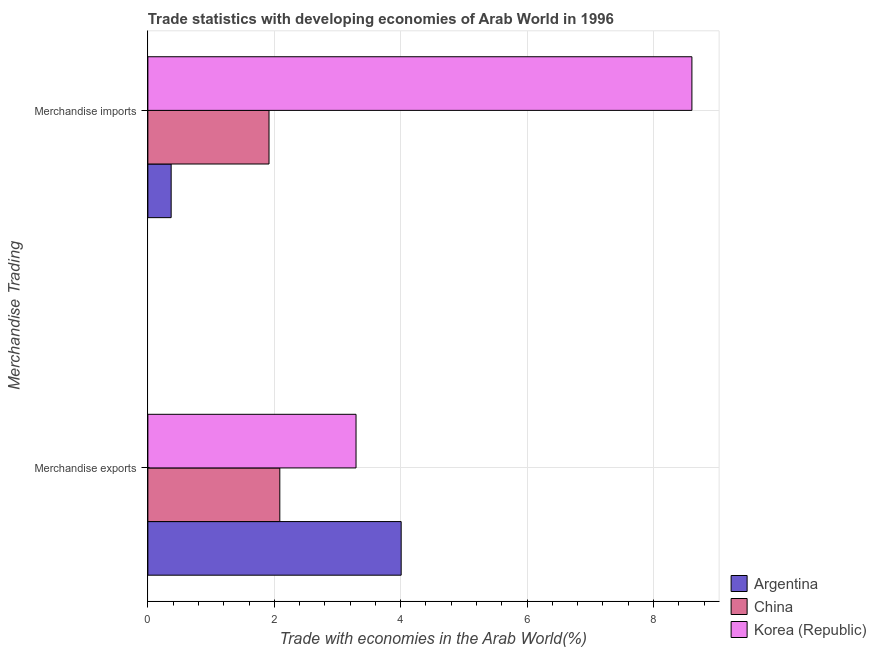How many different coloured bars are there?
Offer a very short reply. 3. How many groups of bars are there?
Keep it short and to the point. 2. Are the number of bars on each tick of the Y-axis equal?
Provide a succinct answer. Yes. How many bars are there on the 2nd tick from the bottom?
Your answer should be compact. 3. What is the label of the 1st group of bars from the top?
Offer a very short reply. Merchandise imports. What is the merchandise exports in Argentina?
Keep it short and to the point. 4.01. Across all countries, what is the maximum merchandise exports?
Your answer should be compact. 4.01. Across all countries, what is the minimum merchandise exports?
Give a very brief answer. 2.09. In which country was the merchandise exports maximum?
Your answer should be very brief. Argentina. In which country was the merchandise exports minimum?
Provide a succinct answer. China. What is the total merchandise imports in the graph?
Offer a very short reply. 10.89. What is the difference between the merchandise imports in Korea (Republic) and that in Argentina?
Offer a terse response. 8.24. What is the difference between the merchandise imports in China and the merchandise exports in Argentina?
Offer a very short reply. -2.09. What is the average merchandise imports per country?
Give a very brief answer. 3.63. What is the difference between the merchandise imports and merchandise exports in Korea (Republic)?
Your answer should be very brief. 5.31. What is the ratio of the merchandise imports in Argentina to that in Korea (Republic)?
Give a very brief answer. 0.04. Is the merchandise imports in Argentina less than that in Korea (Republic)?
Give a very brief answer. Yes. In how many countries, is the merchandise imports greater than the average merchandise imports taken over all countries?
Your answer should be very brief. 1. What does the 1st bar from the top in Merchandise exports represents?
Your answer should be very brief. Korea (Republic). What does the 3rd bar from the bottom in Merchandise imports represents?
Make the answer very short. Korea (Republic). How many bars are there?
Keep it short and to the point. 6. Are all the bars in the graph horizontal?
Provide a short and direct response. Yes. How many countries are there in the graph?
Your answer should be very brief. 3. What is the difference between two consecutive major ticks on the X-axis?
Ensure brevity in your answer.  2. Are the values on the major ticks of X-axis written in scientific E-notation?
Provide a short and direct response. No. Does the graph contain grids?
Offer a very short reply. Yes. What is the title of the graph?
Your answer should be compact. Trade statistics with developing economies of Arab World in 1996. Does "Israel" appear as one of the legend labels in the graph?
Your answer should be very brief. No. What is the label or title of the X-axis?
Your answer should be compact. Trade with economies in the Arab World(%). What is the label or title of the Y-axis?
Offer a terse response. Merchandise Trading. What is the Trade with economies in the Arab World(%) in Argentina in Merchandise exports?
Ensure brevity in your answer.  4.01. What is the Trade with economies in the Arab World(%) in China in Merchandise exports?
Offer a terse response. 2.09. What is the Trade with economies in the Arab World(%) of Korea (Republic) in Merchandise exports?
Your answer should be compact. 3.29. What is the Trade with economies in the Arab World(%) in Argentina in Merchandise imports?
Your answer should be compact. 0.37. What is the Trade with economies in the Arab World(%) of China in Merchandise imports?
Offer a very short reply. 1.92. What is the Trade with economies in the Arab World(%) in Korea (Republic) in Merchandise imports?
Your answer should be compact. 8.61. Across all Merchandise Trading, what is the maximum Trade with economies in the Arab World(%) of Argentina?
Your response must be concise. 4.01. Across all Merchandise Trading, what is the maximum Trade with economies in the Arab World(%) of China?
Ensure brevity in your answer.  2.09. Across all Merchandise Trading, what is the maximum Trade with economies in the Arab World(%) in Korea (Republic)?
Your response must be concise. 8.61. Across all Merchandise Trading, what is the minimum Trade with economies in the Arab World(%) of Argentina?
Offer a terse response. 0.37. Across all Merchandise Trading, what is the minimum Trade with economies in the Arab World(%) in China?
Ensure brevity in your answer.  1.92. Across all Merchandise Trading, what is the minimum Trade with economies in the Arab World(%) in Korea (Republic)?
Provide a short and direct response. 3.29. What is the total Trade with economies in the Arab World(%) of Argentina in the graph?
Make the answer very short. 4.38. What is the total Trade with economies in the Arab World(%) of China in the graph?
Make the answer very short. 4. What is the total Trade with economies in the Arab World(%) in Korea (Republic) in the graph?
Make the answer very short. 11.9. What is the difference between the Trade with economies in the Arab World(%) in Argentina in Merchandise exports and that in Merchandise imports?
Offer a terse response. 3.64. What is the difference between the Trade with economies in the Arab World(%) in China in Merchandise exports and that in Merchandise imports?
Your answer should be very brief. 0.17. What is the difference between the Trade with economies in the Arab World(%) of Korea (Republic) in Merchandise exports and that in Merchandise imports?
Ensure brevity in your answer.  -5.31. What is the difference between the Trade with economies in the Arab World(%) in Argentina in Merchandise exports and the Trade with economies in the Arab World(%) in China in Merchandise imports?
Make the answer very short. 2.09. What is the difference between the Trade with economies in the Arab World(%) of Argentina in Merchandise exports and the Trade with economies in the Arab World(%) of Korea (Republic) in Merchandise imports?
Provide a succinct answer. -4.6. What is the difference between the Trade with economies in the Arab World(%) of China in Merchandise exports and the Trade with economies in the Arab World(%) of Korea (Republic) in Merchandise imports?
Keep it short and to the point. -6.52. What is the average Trade with economies in the Arab World(%) of Argentina per Merchandise Trading?
Provide a short and direct response. 2.19. What is the average Trade with economies in the Arab World(%) in China per Merchandise Trading?
Ensure brevity in your answer.  2. What is the average Trade with economies in the Arab World(%) in Korea (Republic) per Merchandise Trading?
Offer a terse response. 5.95. What is the difference between the Trade with economies in the Arab World(%) of Argentina and Trade with economies in the Arab World(%) of China in Merchandise exports?
Make the answer very short. 1.92. What is the difference between the Trade with economies in the Arab World(%) of Argentina and Trade with economies in the Arab World(%) of Korea (Republic) in Merchandise exports?
Give a very brief answer. 0.71. What is the difference between the Trade with economies in the Arab World(%) of China and Trade with economies in the Arab World(%) of Korea (Republic) in Merchandise exports?
Offer a very short reply. -1.21. What is the difference between the Trade with economies in the Arab World(%) in Argentina and Trade with economies in the Arab World(%) in China in Merchandise imports?
Offer a terse response. -1.55. What is the difference between the Trade with economies in the Arab World(%) of Argentina and Trade with economies in the Arab World(%) of Korea (Republic) in Merchandise imports?
Ensure brevity in your answer.  -8.24. What is the difference between the Trade with economies in the Arab World(%) in China and Trade with economies in the Arab World(%) in Korea (Republic) in Merchandise imports?
Ensure brevity in your answer.  -6.69. What is the ratio of the Trade with economies in the Arab World(%) in Argentina in Merchandise exports to that in Merchandise imports?
Provide a succinct answer. 10.88. What is the ratio of the Trade with economies in the Arab World(%) of China in Merchandise exports to that in Merchandise imports?
Make the answer very short. 1.09. What is the ratio of the Trade with economies in the Arab World(%) of Korea (Republic) in Merchandise exports to that in Merchandise imports?
Your answer should be compact. 0.38. What is the difference between the highest and the second highest Trade with economies in the Arab World(%) in Argentina?
Your answer should be very brief. 3.64. What is the difference between the highest and the second highest Trade with economies in the Arab World(%) in China?
Provide a short and direct response. 0.17. What is the difference between the highest and the second highest Trade with economies in the Arab World(%) in Korea (Republic)?
Offer a very short reply. 5.31. What is the difference between the highest and the lowest Trade with economies in the Arab World(%) in Argentina?
Keep it short and to the point. 3.64. What is the difference between the highest and the lowest Trade with economies in the Arab World(%) in China?
Your response must be concise. 0.17. What is the difference between the highest and the lowest Trade with economies in the Arab World(%) in Korea (Republic)?
Your answer should be compact. 5.31. 